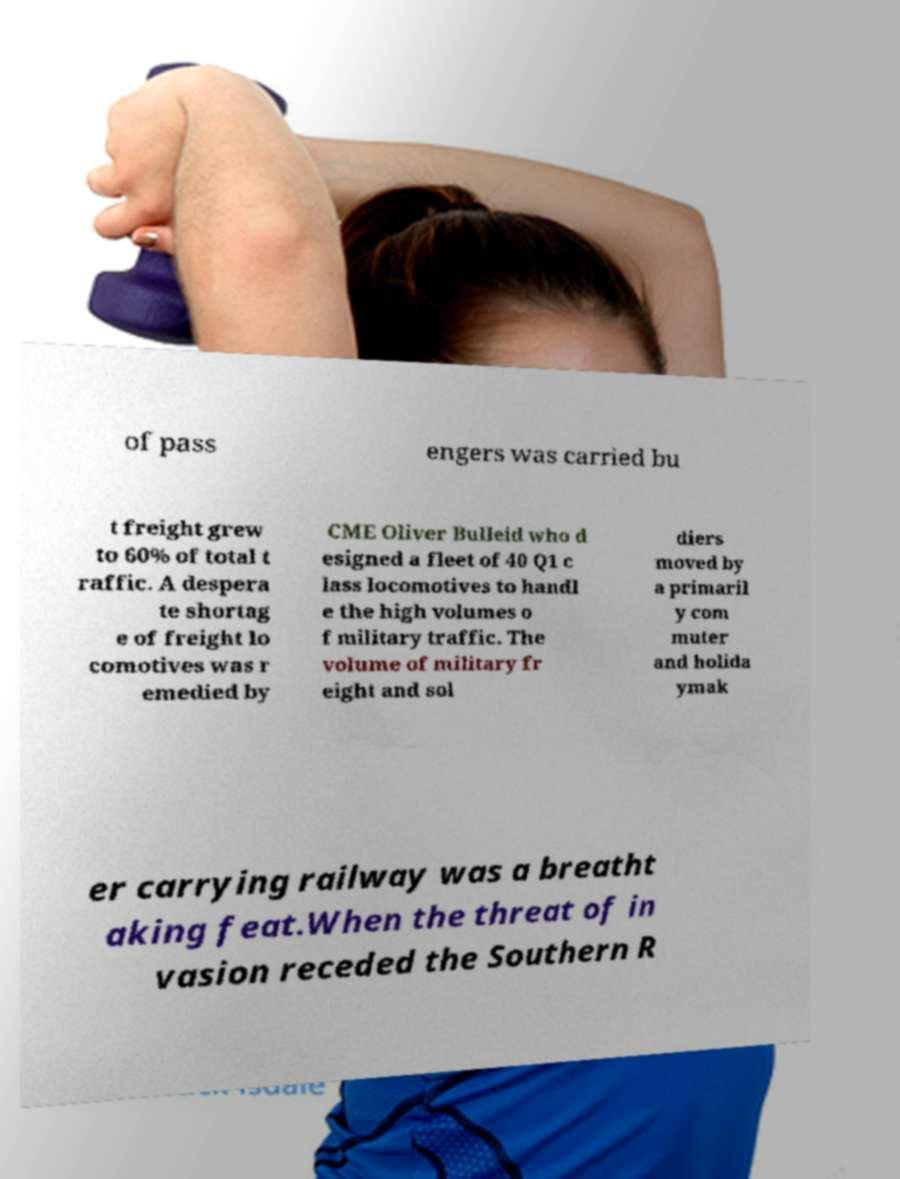I need the written content from this picture converted into text. Can you do that? of pass engers was carried bu t freight grew to 60% of total t raffic. A despera te shortag e of freight lo comotives was r emedied by CME Oliver Bulleid who d esigned a fleet of 40 Q1 c lass locomotives to handl e the high volumes o f military traffic. The volume of military fr eight and sol diers moved by a primaril y com muter and holida ymak er carrying railway was a breatht aking feat.When the threat of in vasion receded the Southern R 